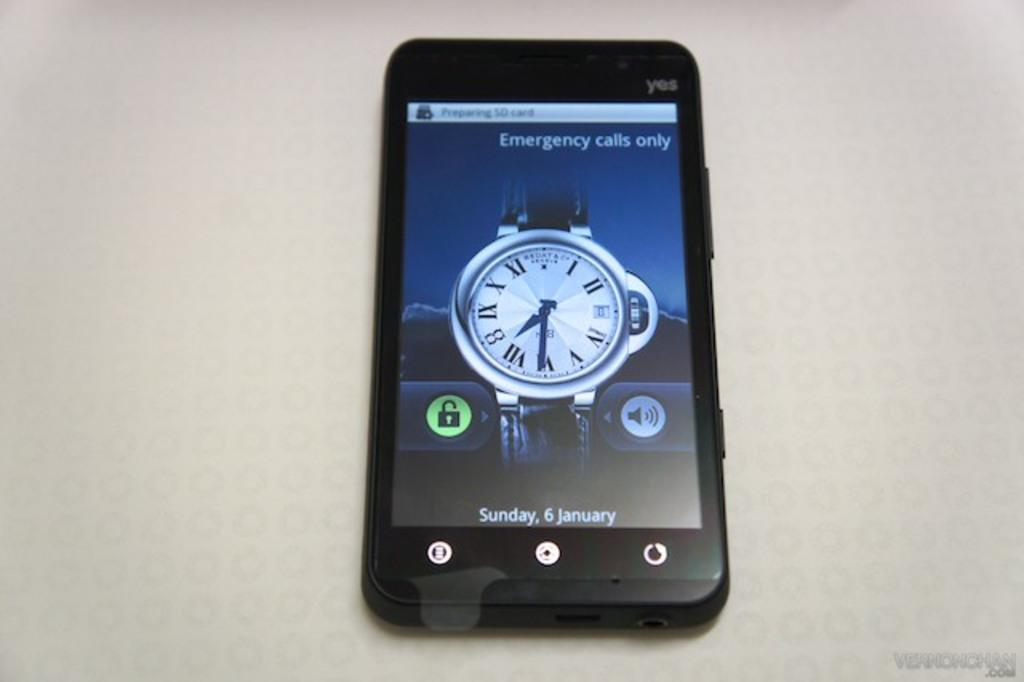Provide a one-sentence caption for the provided image. Phone screen that has the date on January 6th. 